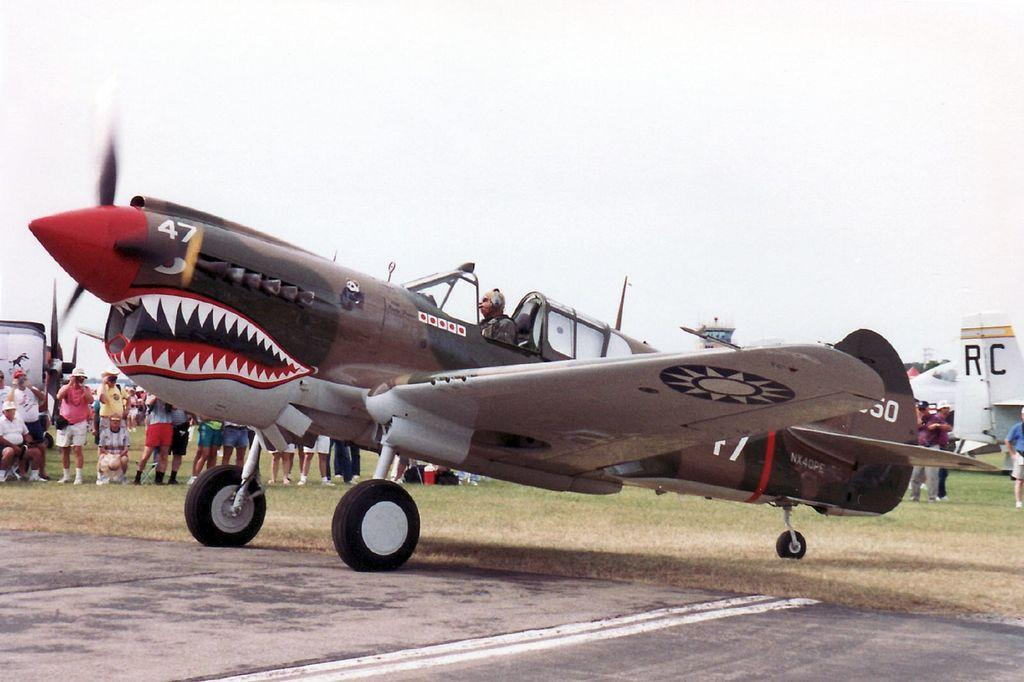Provide a one-sentence caption for the provided image. A plane has a mouth and teeth painted on it and the number 47. 